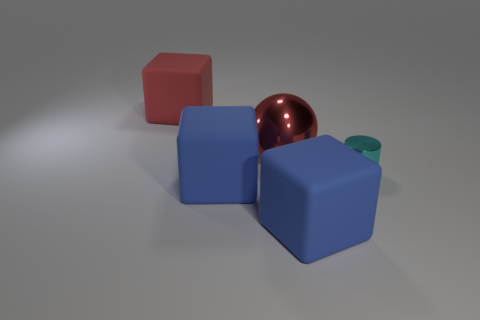There is a large shiny sphere; are there any big rubber objects behind it?
Keep it short and to the point. Yes. The cylinder has what size?
Your answer should be compact. Small. What number of big objects are left of the block behind the cyan cylinder?
Provide a succinct answer. 0. Do the big block that is behind the cylinder and the tiny cylinder in front of the metallic sphere have the same material?
Make the answer very short. No. How many big blue objects have the same shape as the large red matte object?
Give a very brief answer. 2. How many big shiny things have the same color as the sphere?
Keep it short and to the point. 0. Do the large matte object behind the cyan thing and the large red thing that is right of the big red rubber object have the same shape?
Keep it short and to the point. No. There is a large blue object that is left of the big object that is to the right of the metal ball; how many rubber things are behind it?
Offer a very short reply. 1. What material is the big red thing that is left of the red thing right of the matte block that is behind the large red shiny object?
Give a very brief answer. Rubber. Is the material of the large red thing that is to the right of the large red rubber block the same as the cyan cylinder?
Ensure brevity in your answer.  Yes. 